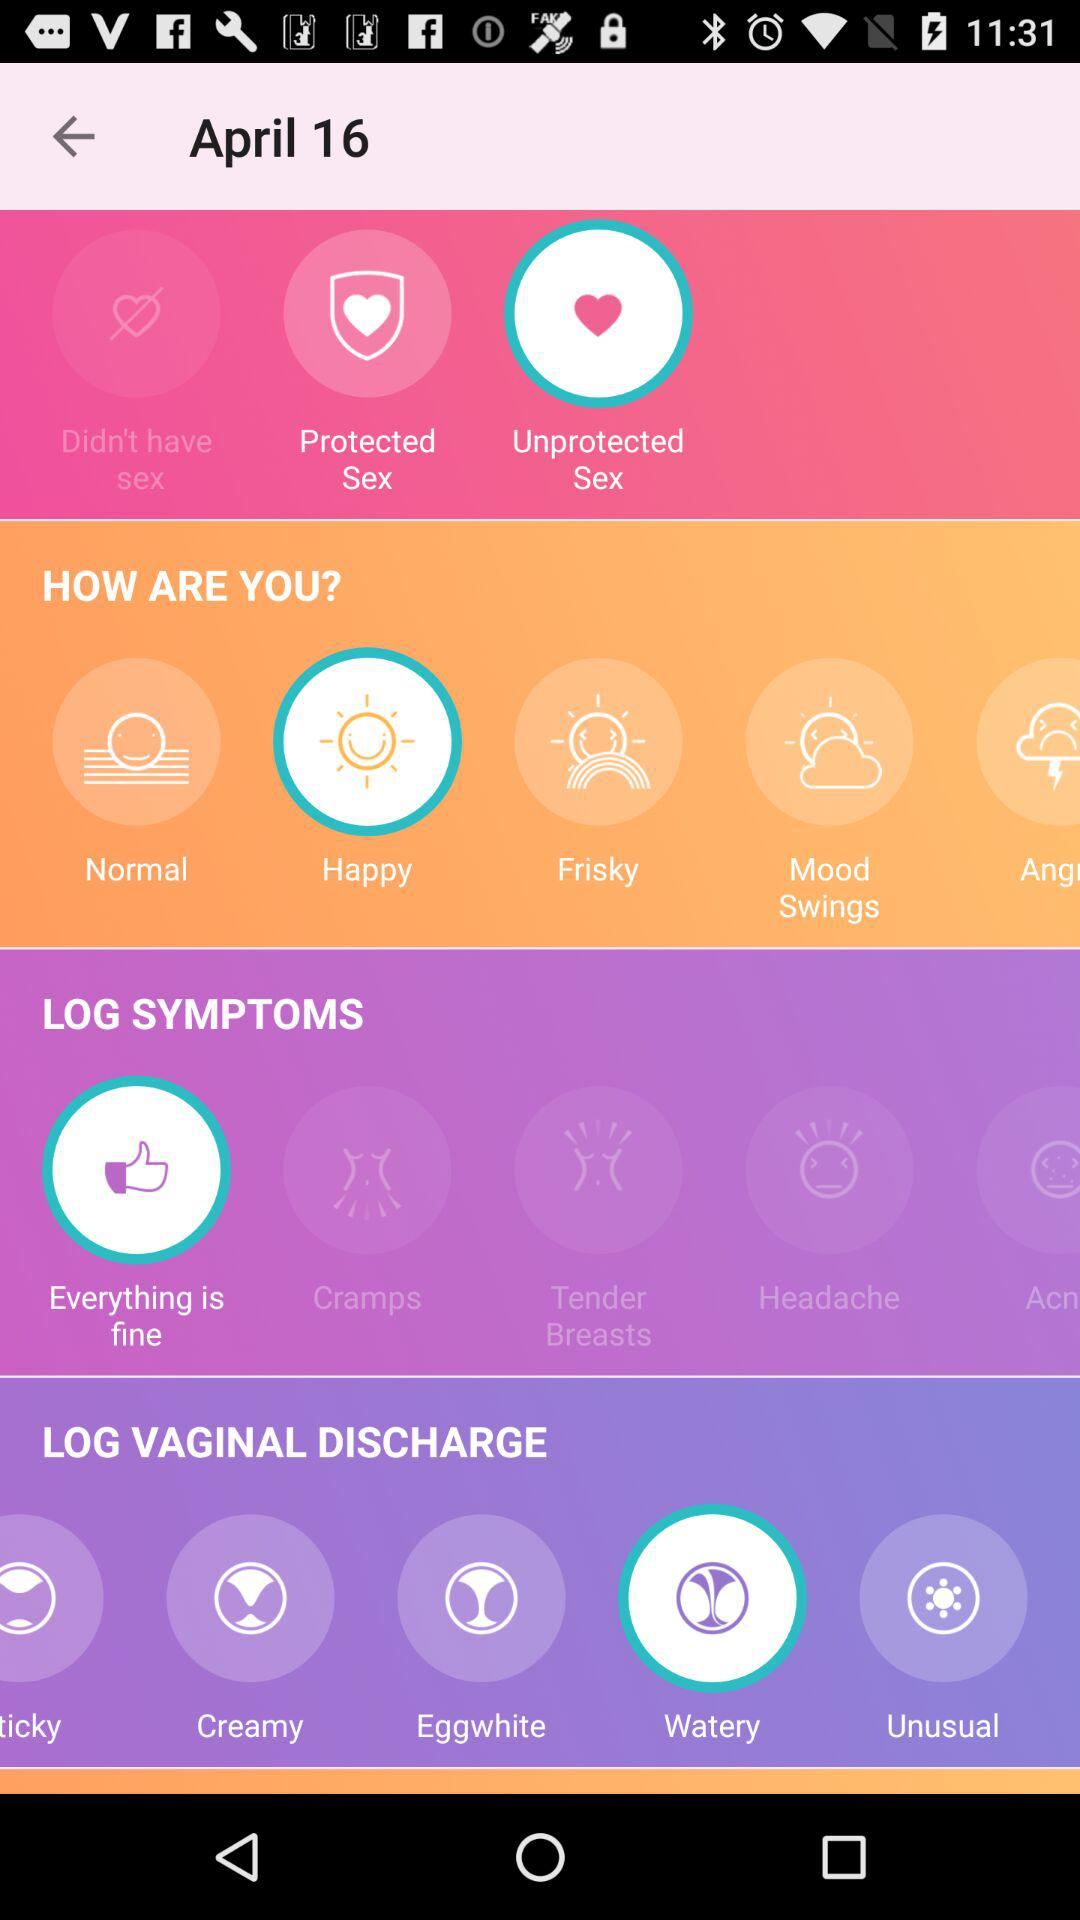Which option is selected in "LOG SYMPTOMS"? The selected option in "LOG SYMPTOMS" is "Everything is fine". 